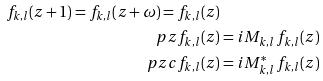Convert formula to latex. <formula><loc_0><loc_0><loc_500><loc_500>f _ { k , l } ( z + 1 ) = f _ { k , l } ( z + \omega ) = f _ { k , l } ( z ) \\ \ p z f _ { k , l } ( z ) & = i M _ { k , l } \, f _ { k , l } ( z ) \\ \ p z c f _ { k , l } ( z ) & = i M ^ { * } _ { k , l } \, f _ { k , l } ( z )</formula> 